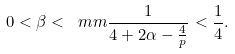<formula> <loc_0><loc_0><loc_500><loc_500>0 < \beta < \ m m { \frac { 1 } { 4 + 2 \alpha - \frac { 4 } { p } } } < \frac { 1 } { 4 } .</formula> 